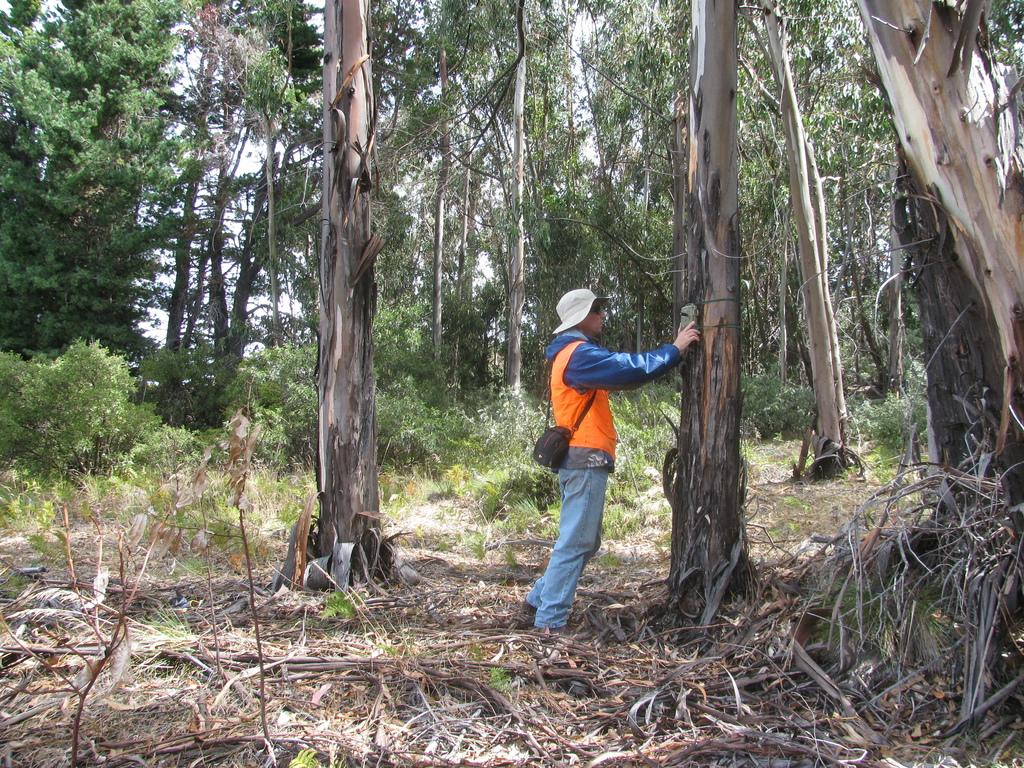What is the main subject in the image? There is a person standing in the image. What type of vegetation can be seen in the image? There are plants and trees in the image. What type of bomb is being used to solve arithmetic problems in the image? There is no bomb or arithmetic problem present in the image; it features a person standing among plants and trees. How many birds can be seen flying in the image? There are no birds visible in the image; the image only shows a person standing among plants and trees. 